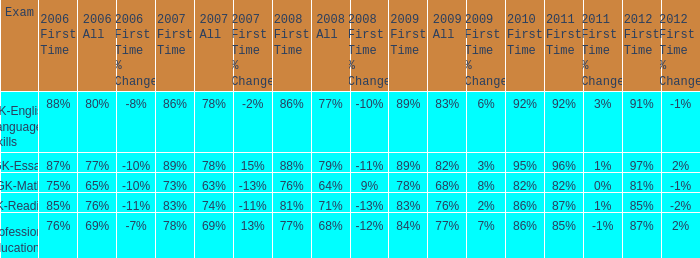What is the percentage for all in 2008 when all in 2007 was 69%? 68%. 